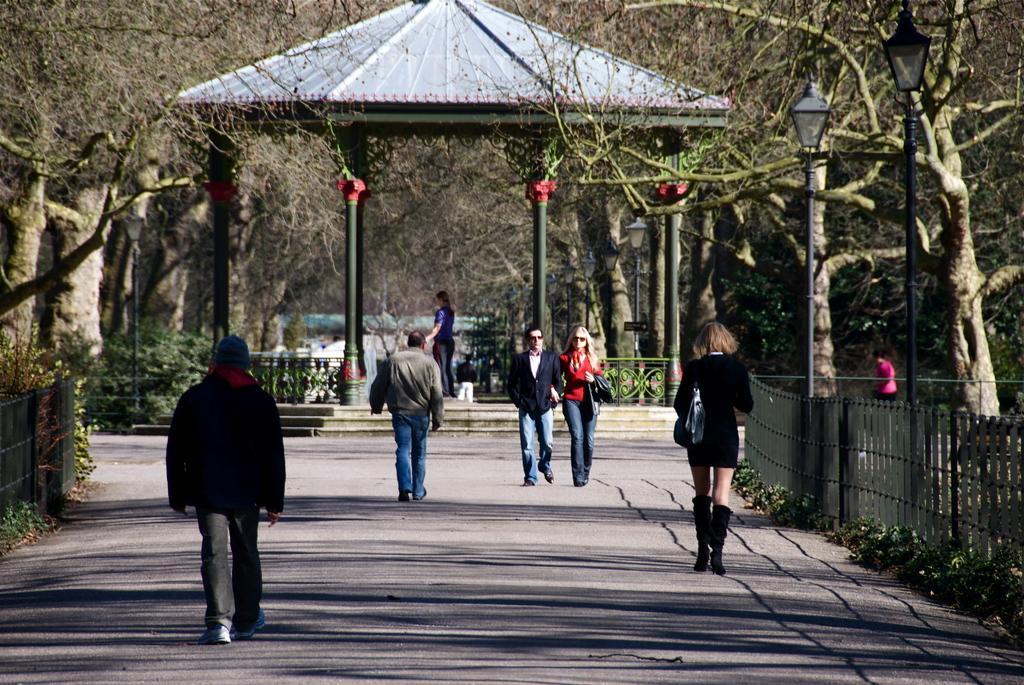Can you describe this image briefly? in this image we can see some people walking on the road and there are some trees and plants. We can see a fence and in the background, there is a shed and there are two street lights. 